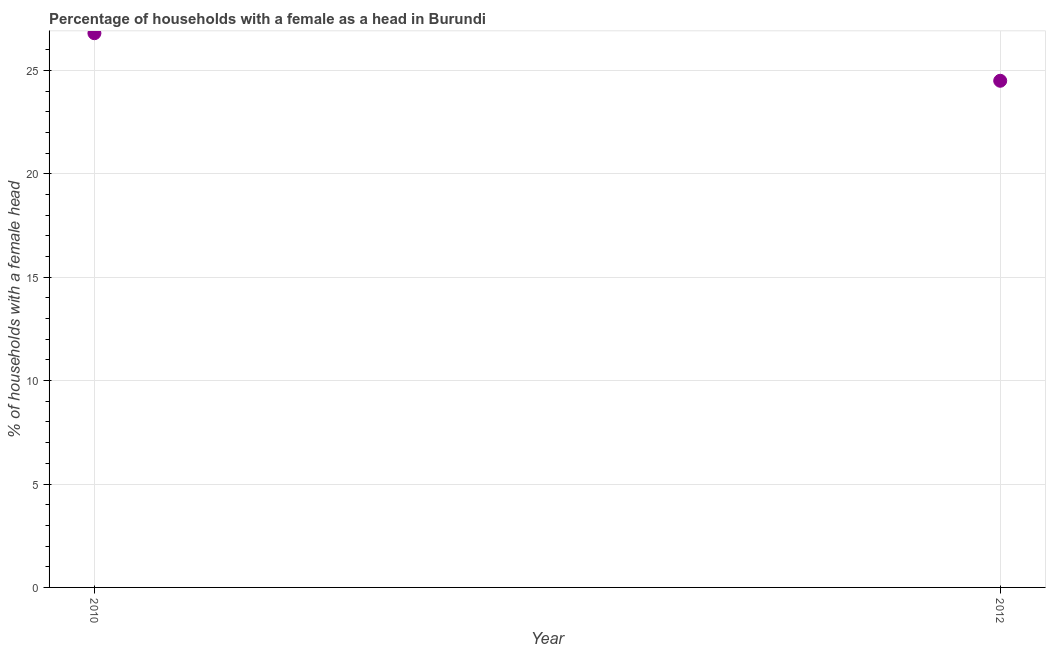What is the number of female supervised households in 2010?
Your answer should be very brief. 26.8. Across all years, what is the maximum number of female supervised households?
Make the answer very short. 26.8. Across all years, what is the minimum number of female supervised households?
Offer a terse response. 24.5. What is the sum of the number of female supervised households?
Provide a short and direct response. 51.3. What is the difference between the number of female supervised households in 2010 and 2012?
Your answer should be compact. 2.3. What is the average number of female supervised households per year?
Keep it short and to the point. 25.65. What is the median number of female supervised households?
Provide a succinct answer. 25.65. In how many years, is the number of female supervised households greater than 17 %?
Ensure brevity in your answer.  2. What is the ratio of the number of female supervised households in 2010 to that in 2012?
Provide a succinct answer. 1.09. In how many years, is the number of female supervised households greater than the average number of female supervised households taken over all years?
Offer a very short reply. 1. Does the number of female supervised households monotonically increase over the years?
Your response must be concise. No. How many dotlines are there?
Your answer should be very brief. 1. Does the graph contain grids?
Your response must be concise. Yes. What is the title of the graph?
Make the answer very short. Percentage of households with a female as a head in Burundi. What is the label or title of the X-axis?
Ensure brevity in your answer.  Year. What is the label or title of the Y-axis?
Offer a very short reply. % of households with a female head. What is the % of households with a female head in 2010?
Offer a terse response. 26.8. What is the % of households with a female head in 2012?
Keep it short and to the point. 24.5. What is the difference between the % of households with a female head in 2010 and 2012?
Your answer should be compact. 2.3. What is the ratio of the % of households with a female head in 2010 to that in 2012?
Provide a succinct answer. 1.09. 